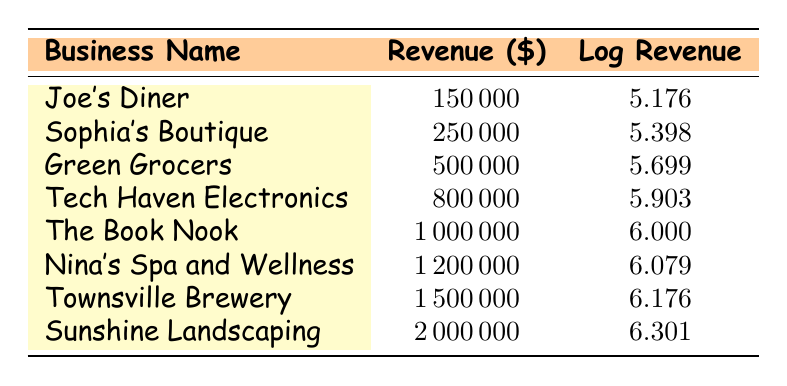What is the revenue of Joe's Diner? The table lists Joe's Diner under the Business Name column with a corresponding Revenue value of 150000 in the Revenue (\$) column.
Answer: 150000 Which business has the highest revenue? By examining the Revenue column, Townsville Brewery is listed with a revenue of 1500000, which is the highest value compared to other businesses.
Answer: Townsville Brewery Is Sophia's Boutique revenue greater than 200000? The table shows Sophia's Boutique has a revenue of 250000. Since 250000 is greater than 200000, the statement is true.
Answer: Yes What is the revenue difference between Green Grocers and Tech Haven Electronics? Green Grocers has a revenue of 500000 and Tech Haven Electronics has a revenue of 800000. The difference is calculated as 800000 - 500000 = 300000.
Answer: 300000 What is the average revenue of the businesses listed? To find the average, first sum all revenues: 150000 + 250000 + 500000 + 800000 + 1000000 + 1200000 + 1500000 + 2000000 = 7500000. There are 8 businesses, so the average is 7500000 / 8 = 937500.
Answer: 937500 Is there a business with a revenue less than 2000000? Checking the Revenue column, all listed businesses have revenues below 2000000, thus confirming that there are businesses fitting this criterion.
Answer: Yes What is the log revenue of Nina's Spa and Wellness? The table associates Nina's Spa and Wellness with a log revenue value of 6.079. This information is directly taken from the Log Revenue column beside Nina's Spa and Wellness.
Answer: 6.079 Which business's log revenue is closest to 6? The log revenue of The Book Nook is exactly 6.000 and is the only entry at this value when compared to all the other log revenue entries.
Answer: The Book Nook How many businesses have a log revenue greater than 5.5? Listing the log revenue values, Joe's Diner (5.176), Sophia's Boutique (5.398), and Green Grocers (5.699) are less than or equal to 5.5. The remaining businesses have log revenues above 5.5, making it 5 total businesses with log revenue greater than 5.5.
Answer: 5 